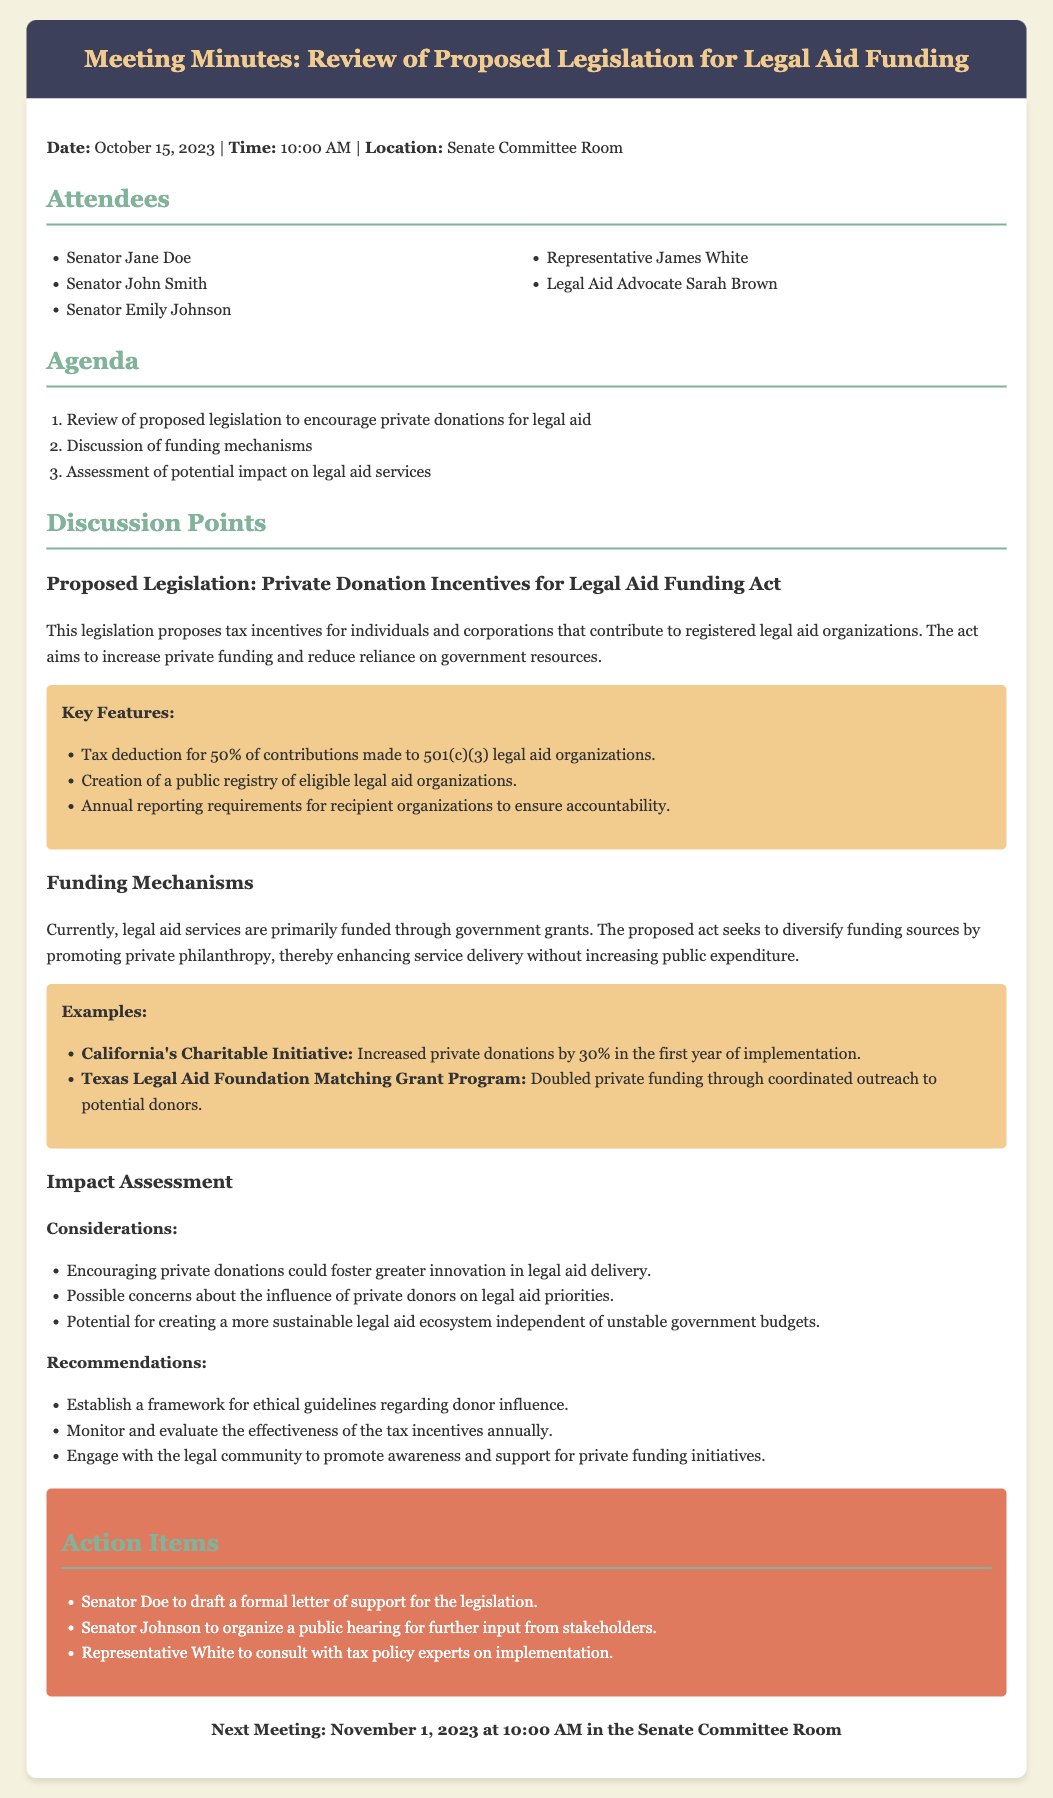What is the title of the proposed legislation? The title of the proposed legislation is mentioned in the discussion points as "Private Donation Incentives for Legal Aid Funding Act."
Answer: Private Donation Incentives for Legal Aid Funding Act What percentage of contributions can be deducted according to the proposed legislation? The document states that there is a tax deduction for 50% of contributions made to legal aid organizations.
Answer: 50% Who is responsible for drafting a formal letter of support for the legislation? The action items list indicates that Senator Doe is tasked with drafting the formal letter of support for the legislation.
Answer: Senator Doe What is one example of a successful funding mechanism from the document? The discussion provides California's Charitable Initiative as an example that increased private donations by 30%.
Answer: California's Charitable Initiative What is the date and time of the next meeting? The document specifies that the next meeting is scheduled for November 1, 2023, at 10:00 AM.
Answer: November 1, 2023 at 10:00 AM What are the potential concerns regarding private donations mentioned in the document? The impact assessment outlines possible concerns regarding the influence of private donors on legal aid priorities.
Answer: Influence of private donors on legal aid priorities What is one recommendation for engaging with the legal community? The document suggests engaging with the legal community to promote awareness and support for private funding initiatives as a recommendation.
Answer: Promote awareness and support for private funding initiatives How many attendees were present at the meeting? The attendees list shows that there are five individuals present during the meeting.
Answer: Five 